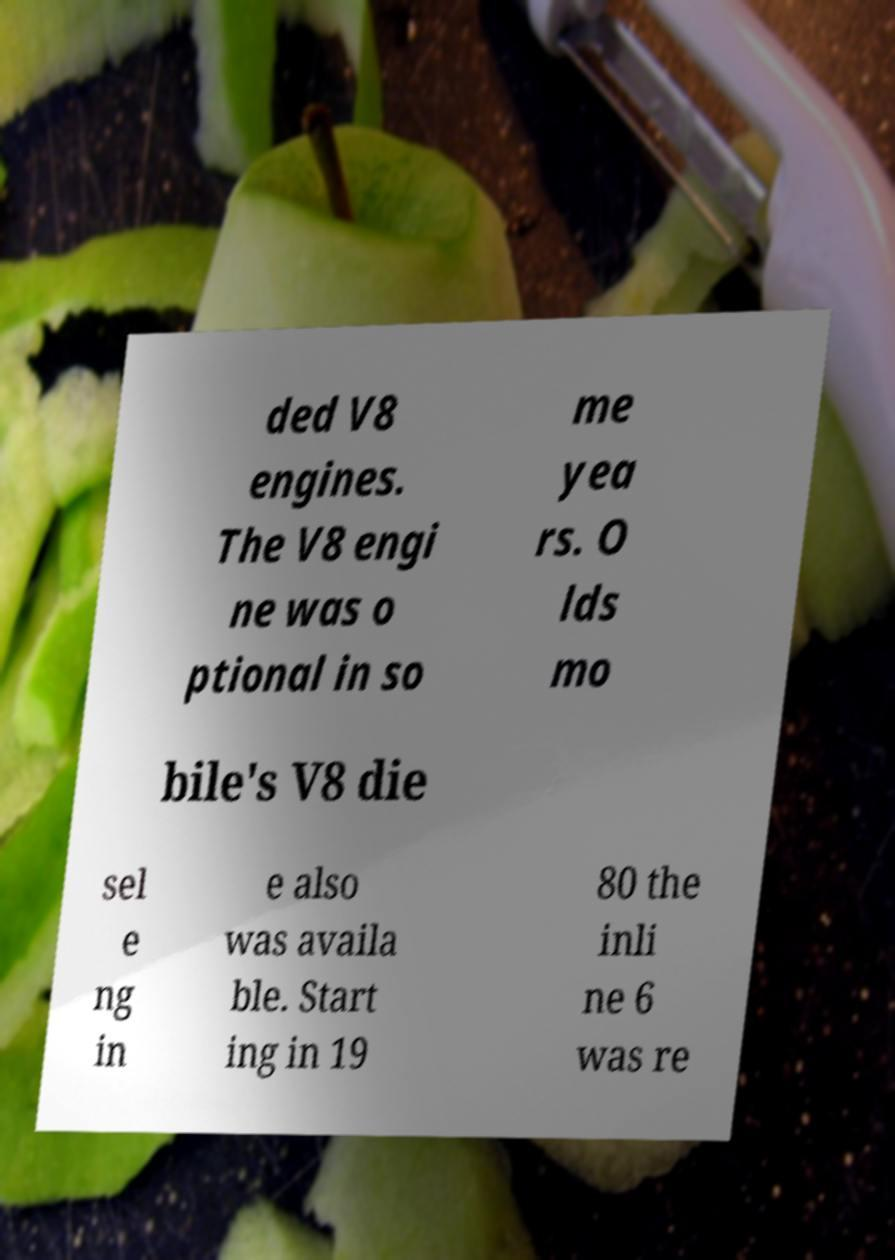Can you accurately transcribe the text from the provided image for me? ded V8 engines. The V8 engi ne was o ptional in so me yea rs. O lds mo bile's V8 die sel e ng in e also was availa ble. Start ing in 19 80 the inli ne 6 was re 